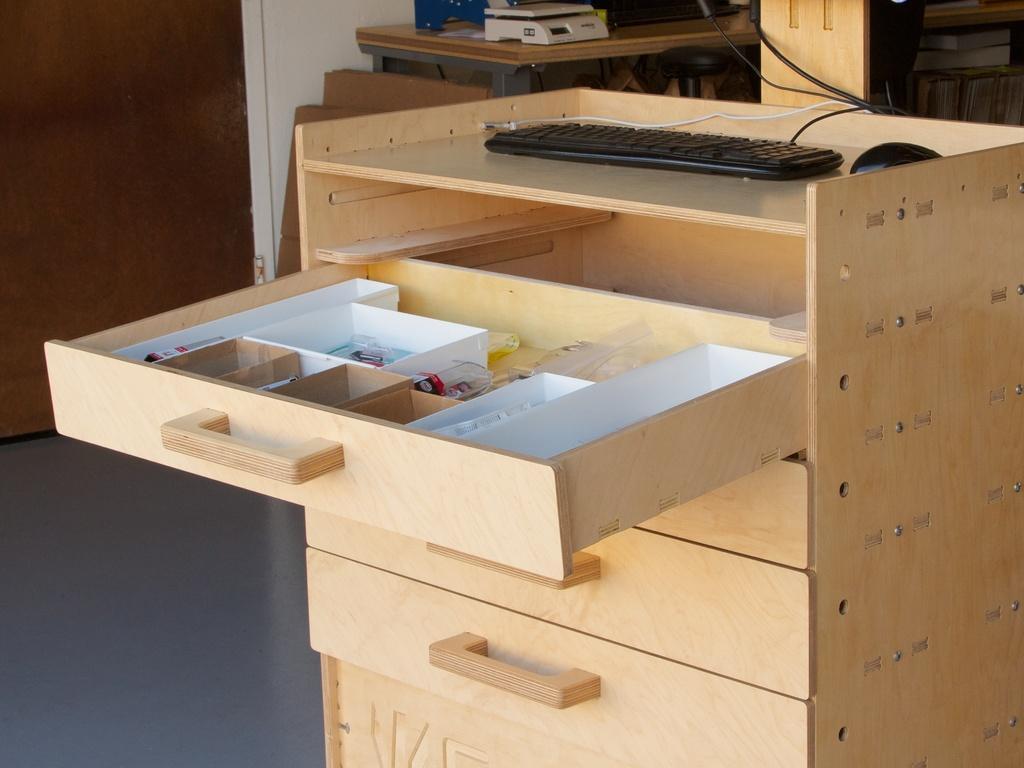Describe this image in one or two sentences. In this picture I can see the keyboard and mouse on this table. In the center I can see on one of the drawer is opened. In the drawer I can see the plastic objects. At the top I can see the weight machine and other objects on the table. On the left there is a door. In the top right corner I can see some chairs near to the wall. 